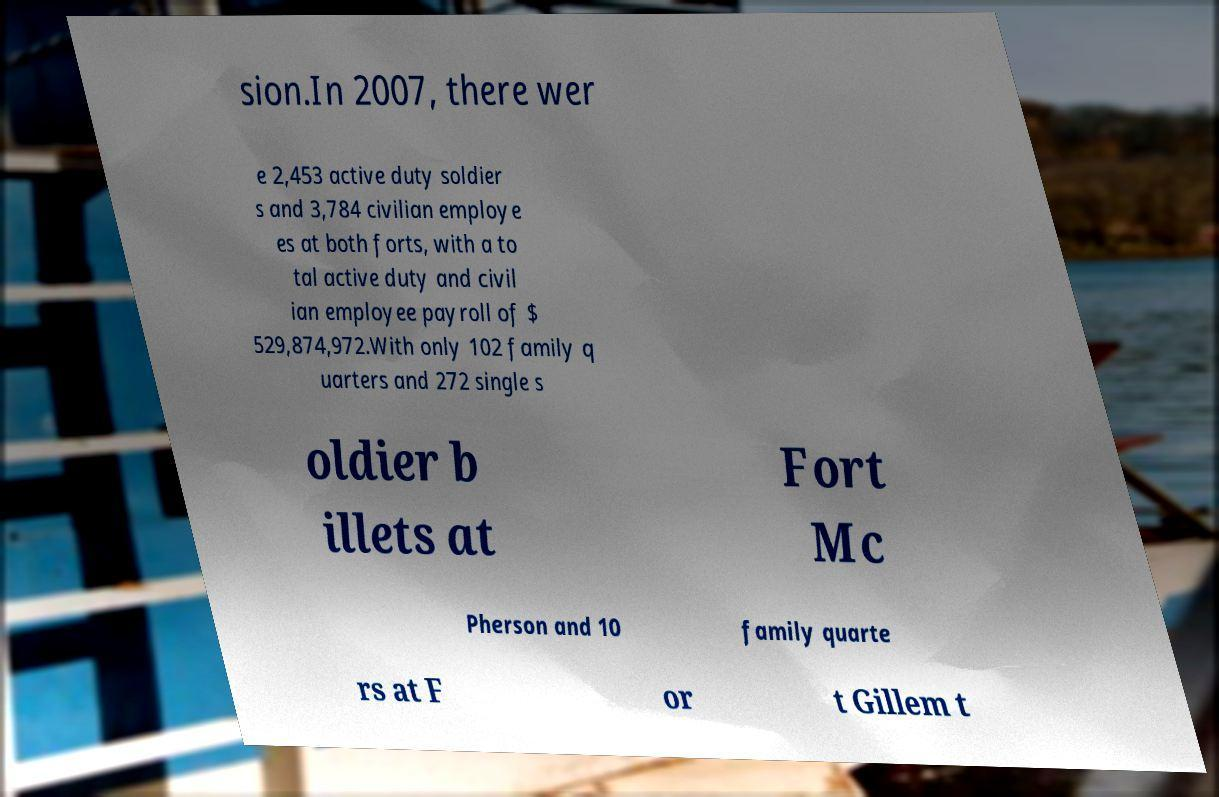Could you assist in decoding the text presented in this image and type it out clearly? sion.In 2007, there wer e 2,453 active duty soldier s and 3,784 civilian employe es at both forts, with a to tal active duty and civil ian employee payroll of $ 529,874,972.With only 102 family q uarters and 272 single s oldier b illets at Fort Mc Pherson and 10 family quarte rs at F or t Gillem t 